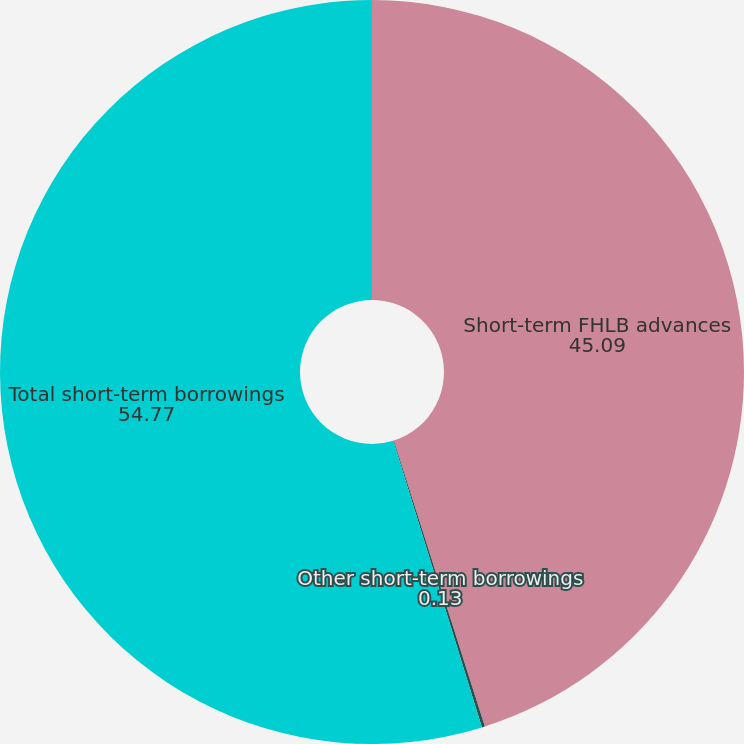Convert chart. <chart><loc_0><loc_0><loc_500><loc_500><pie_chart><fcel>Short-term FHLB advances<fcel>Other short-term borrowings<fcel>Total short-term borrowings<nl><fcel>45.09%<fcel>0.13%<fcel>54.77%<nl></chart> 